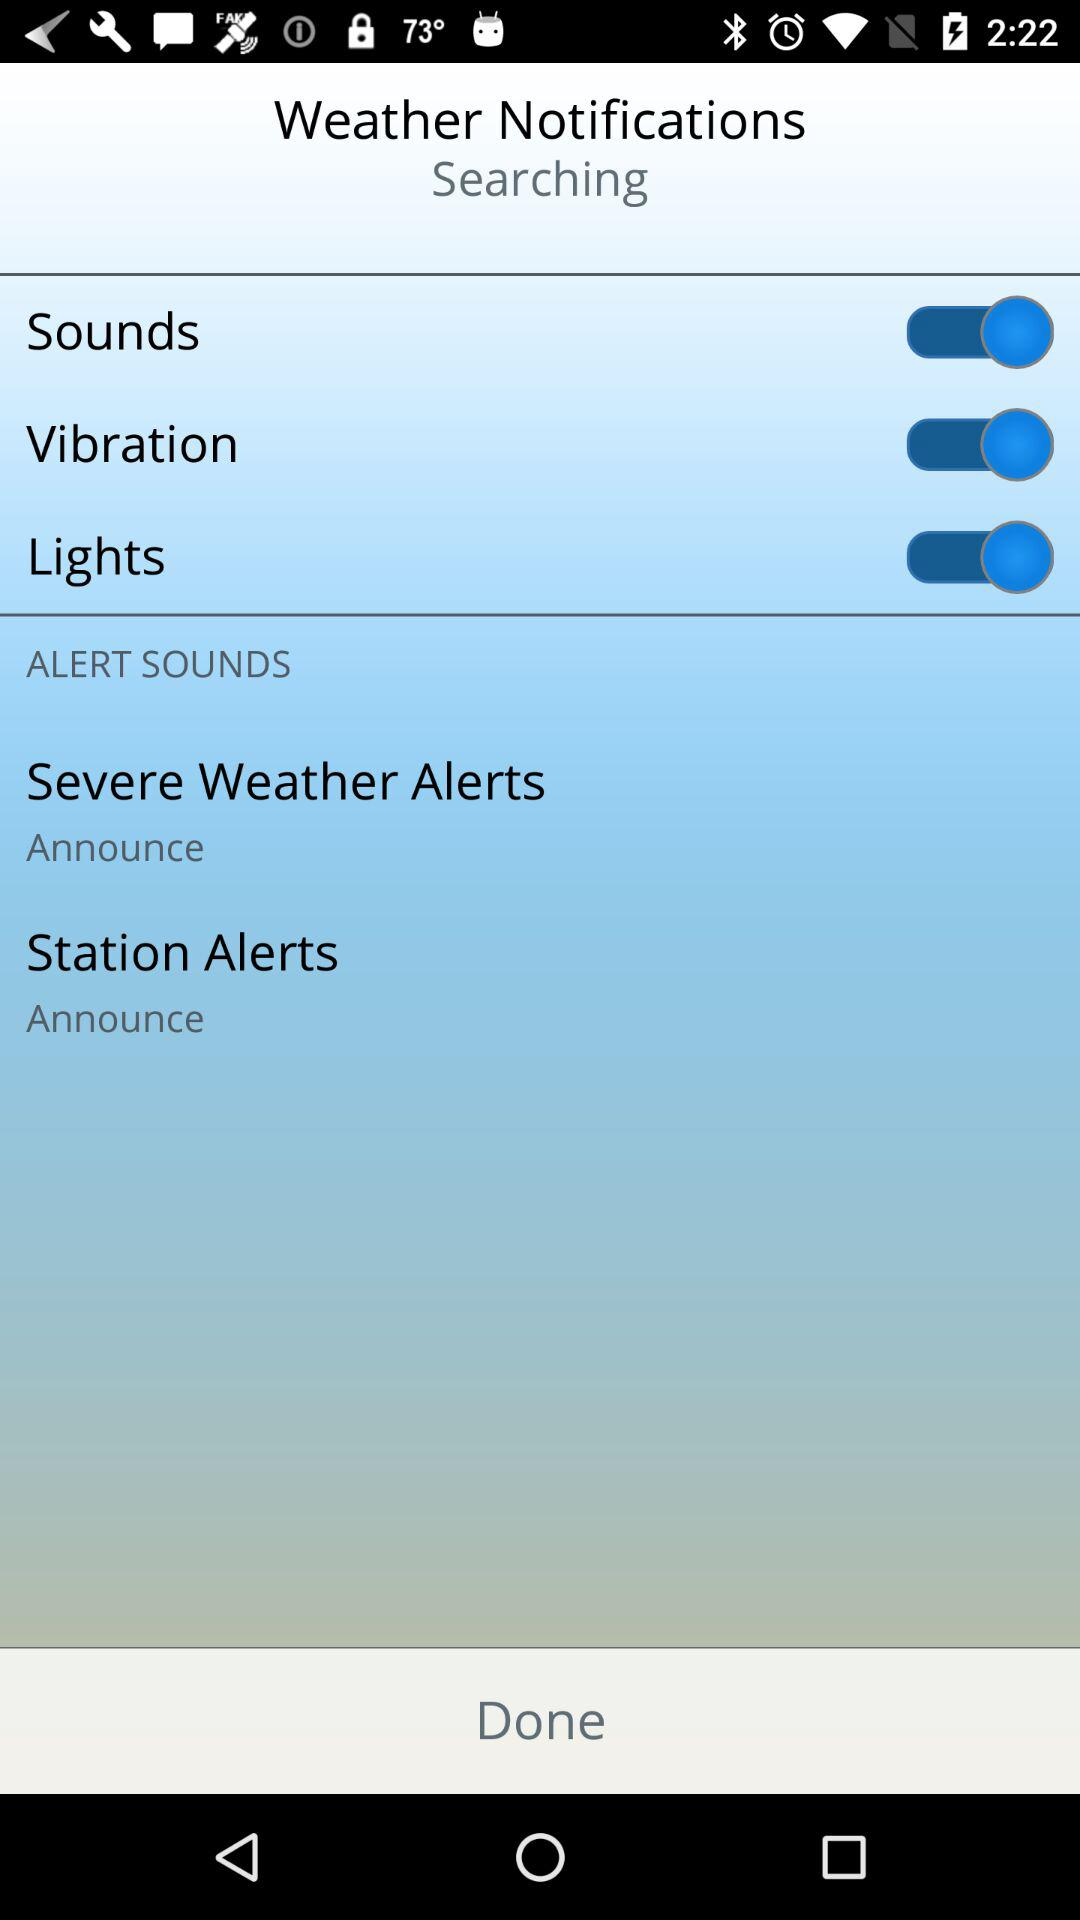How many more Alert Sounds items are there than Sounds items?
Answer the question using a single word or phrase. 2 